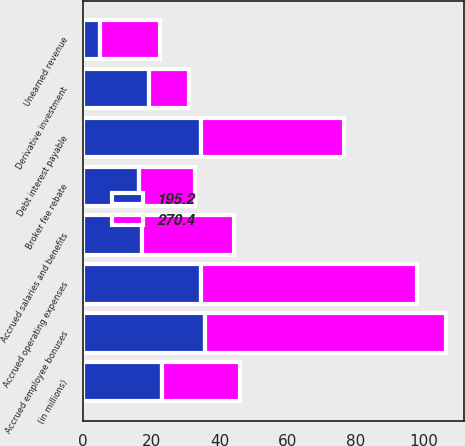<chart> <loc_0><loc_0><loc_500><loc_500><stacked_bar_chart><ecel><fcel>(in millions)<fcel>Accrued employee bonuses<fcel>Accrued operating expenses<fcel>Debt interest payable<fcel>Accrued salaries and benefits<fcel>Unearned revenue<fcel>Broker fee rebate<fcel>Derivative investment<nl><fcel>270.4<fcel>23.05<fcel>70.7<fcel>63.3<fcel>42.1<fcel>26.8<fcel>17.6<fcel>16.3<fcel>11.8<nl><fcel>195.2<fcel>23.05<fcel>35.9<fcel>34.7<fcel>34.6<fcel>17.4<fcel>4.9<fcel>16.4<fcel>19.3<nl></chart> 